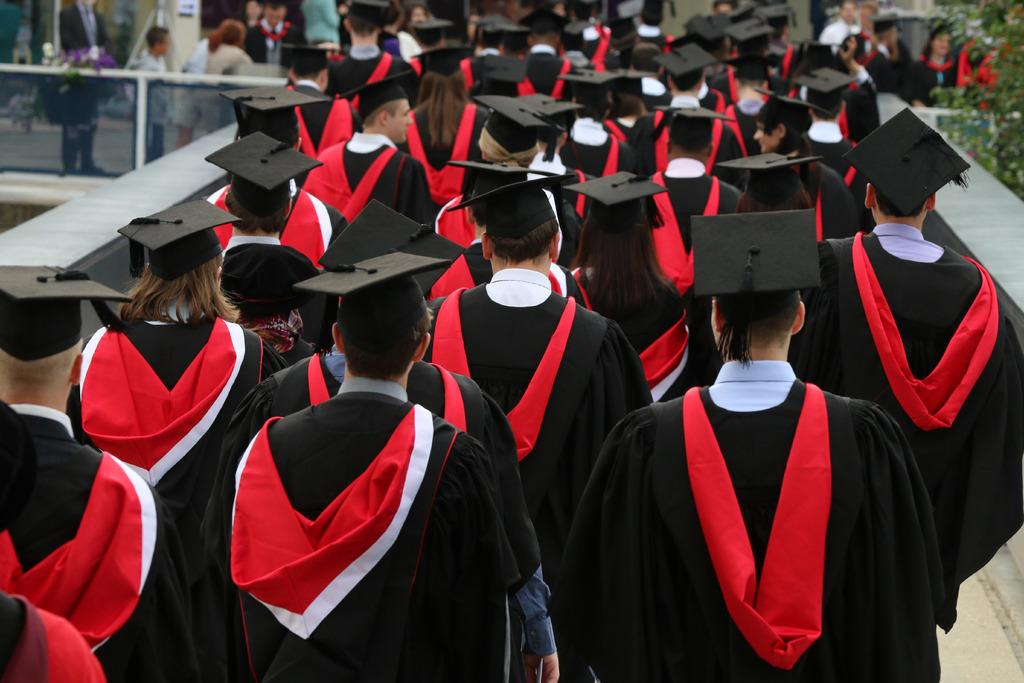What are the people in the image wearing? The people in the image are wearing graduation dresses. What are the people in graduation dresses doing? The people are walking on a bridge. Can you describe the background of the image? There are people standing in the background of the image. Is there any vegetation visible in the image? Yes, there is a plant in the top right corner of the image. What type of animal can be seen interacting with the people on the bridge in the image? There is no animal present in the image; it only features people wearing graduation dresses walking on a bridge. What is the acoustics like in the image? The acoustics cannot be determined from the image, as it only shows people walking on a bridge and does not provide any information about the sound environment. 